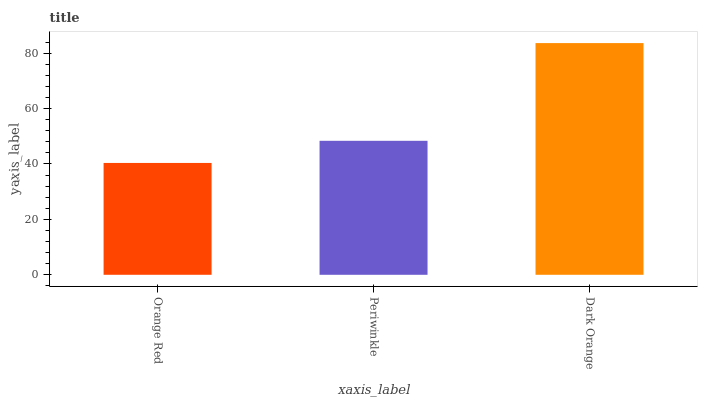Is Periwinkle the minimum?
Answer yes or no. No. Is Periwinkle the maximum?
Answer yes or no. No. Is Periwinkle greater than Orange Red?
Answer yes or no. Yes. Is Orange Red less than Periwinkle?
Answer yes or no. Yes. Is Orange Red greater than Periwinkle?
Answer yes or no. No. Is Periwinkle less than Orange Red?
Answer yes or no. No. Is Periwinkle the high median?
Answer yes or no. Yes. Is Periwinkle the low median?
Answer yes or no. Yes. Is Orange Red the high median?
Answer yes or no. No. Is Orange Red the low median?
Answer yes or no. No. 